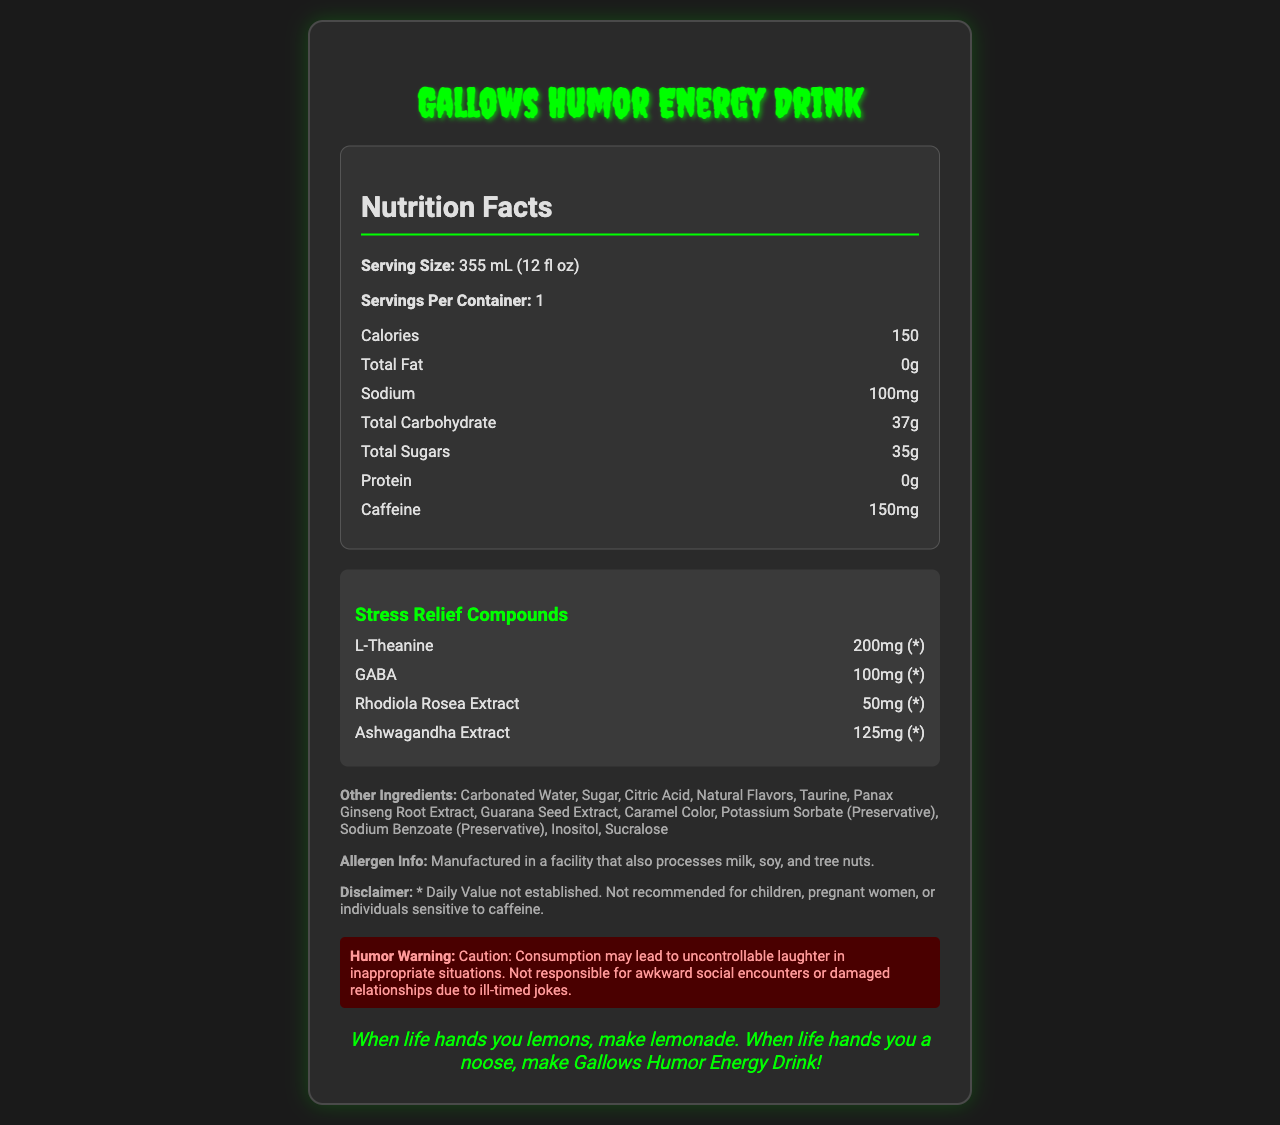what is the serving size of Gallows Humor Energy Drink? The serving size is clearly listed at the beginning of the document as "355 mL (12 fl oz)".
Answer: 355 mL (12 fl oz) how many calories are in one serving? The calories per serving are listed as 150 in the nutrition facts section.
Answer: 150 what are the stress relief compounds included in the drink? These ingredients are listed under the "Stress Relief Compounds" section in the document.
Answer: L-Theanine, GABA, Rhodiola Rosea Extract, Ashwagandha Extract what percentage of the daily value of Vitamin B12 does this drink provide? Under the vitamins and minerals section, Vitamin B12 is listed as providing 250% of the daily value.
Answer: 250% how much caffeine is in the drink? The amount of caffeine is listed in the nutrition facts section as 150mg.
Answer: 150mg which ingredient is NOT part of the other ingredients? A. Citric Acid B. Apple Juice C. Taurine Apple Juice is not listed in the "Other Ingredients" section, while Citric Acid and Taurine are.
Answer: B. Apple Juice which of the following is NOT mentioned in the psychological benefits? 1. Enhances focus 2. Alleviates symptoms of existential dread 3. Increases resilience to stress Enhances focus is not mentioned, while the other two are listed under psychological benefits.
Answer: 1. Enhances focus is the product recommended for children? The disclaimer clearly states, "Not recommended for children...".
Answer: No summarize the main idea of this document. This summary captures the primary details and key points about the drink as presented in the document.
Answer: The document details the nutrition facts for "Gallows Humor Energy Drink", emphasizing its unique combination of ingredients designed to provide energy and stress relief. It includes information on serving size, calories, nutrients, stress-relief compounds, and additional warnings about the product's suitability for certain individuals. what is the tagline of the Gallows Humor Energy Drink? The tagline is located at the bottom of the document in italics.
Answer: "When life hands you lemons, make lemonade. When life hands you a noose, make Gallows Humor Energy Drink!" what is the total amount of sugar in the drink? The total sugars are listed in the nutrition facts section as 35g.
Answer: 35g are there any allergens mentioned in the document? The allergen information states that the product is manufactured in a facility that also processes milk, soy, and tree nuts.
Answer: Yes how much Sodium is present? The amount of Sodium is listed in the nutrition facts section as 100mg.
Answer: 100mg does the drink contain preservatives? The "Other Ingredients" section lists preservatives such as Potassium Sorbate and Sodium Benzoate.
Answer: Yes how much Rhodiola Rosea Extract is included in the drink? Under the stress relief compounds section, Rhodiola Rosea Extract is listed as containing 50mg.
Answer: 50mg how does the product humorously warn consumers? This humorous warning is clearly placed in the document under the section "Humor Warning".
Answer: "Caution: Consumption may lead to uncontrollable laughter in inappropriate situations. Not responsible for awkward social encounters or damaged relationships due to ill-timed jokes." what is the daily value percentage for Niacin in the drink? The daily value for Niacin is listed as 100% in the vitamins and minerals section.
Answer: 100% what can be inferred about the effect of L-Theanine in this drink? The document lists that L-Theanine is included as a stress relief compound but does not explain its specific effects in detail.
Answer: Not enough information 